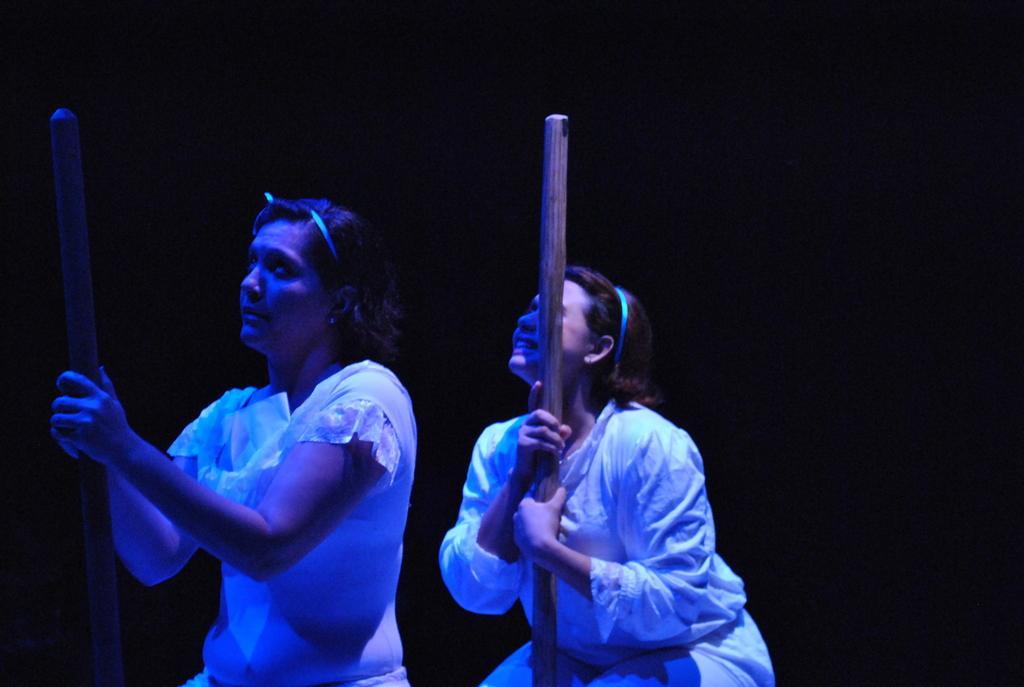Could you give a brief overview of what you see in this image? In this image there are two girls in white dress holding sticks. 